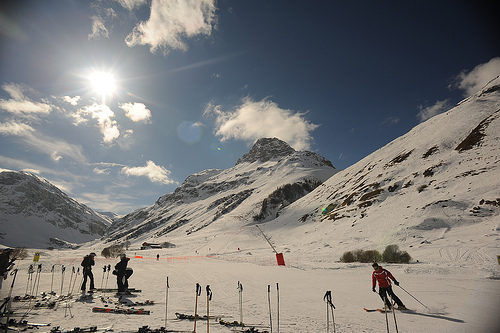What color is the coat that the people are in? The skier closest to the foreground is wearing a red coat, which stands out brightly against the snowy backdrop. 